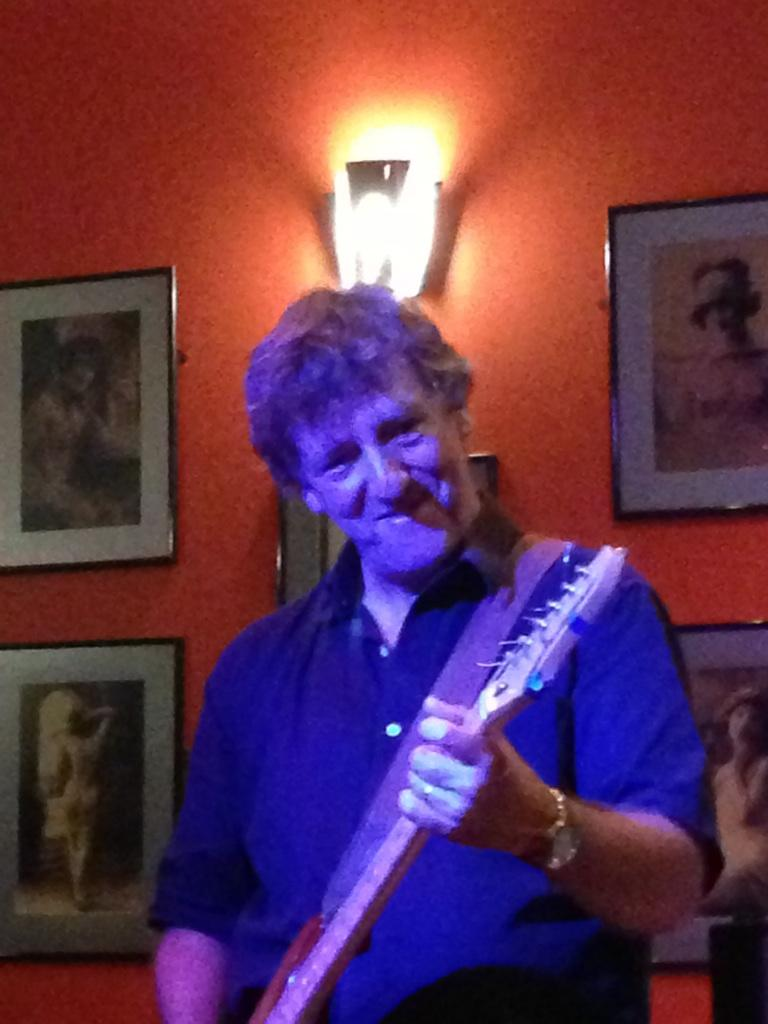Who is present in the image? There is a man in the image. What is the man doing in the image? The man is standing and holding a guitar. What can be seen in the background of the image? There is a wall in the background of the image, and there are photo frames on the wall. Can you describe the lighting in the image? There is a light in the image. What type of toothbrush is the man using in the image? There is no toothbrush present in the image; the man is holding a guitar. Can you hear the sound of thunder in the image? There is no mention of thunder or any sound in the image; it is a still photograph. 